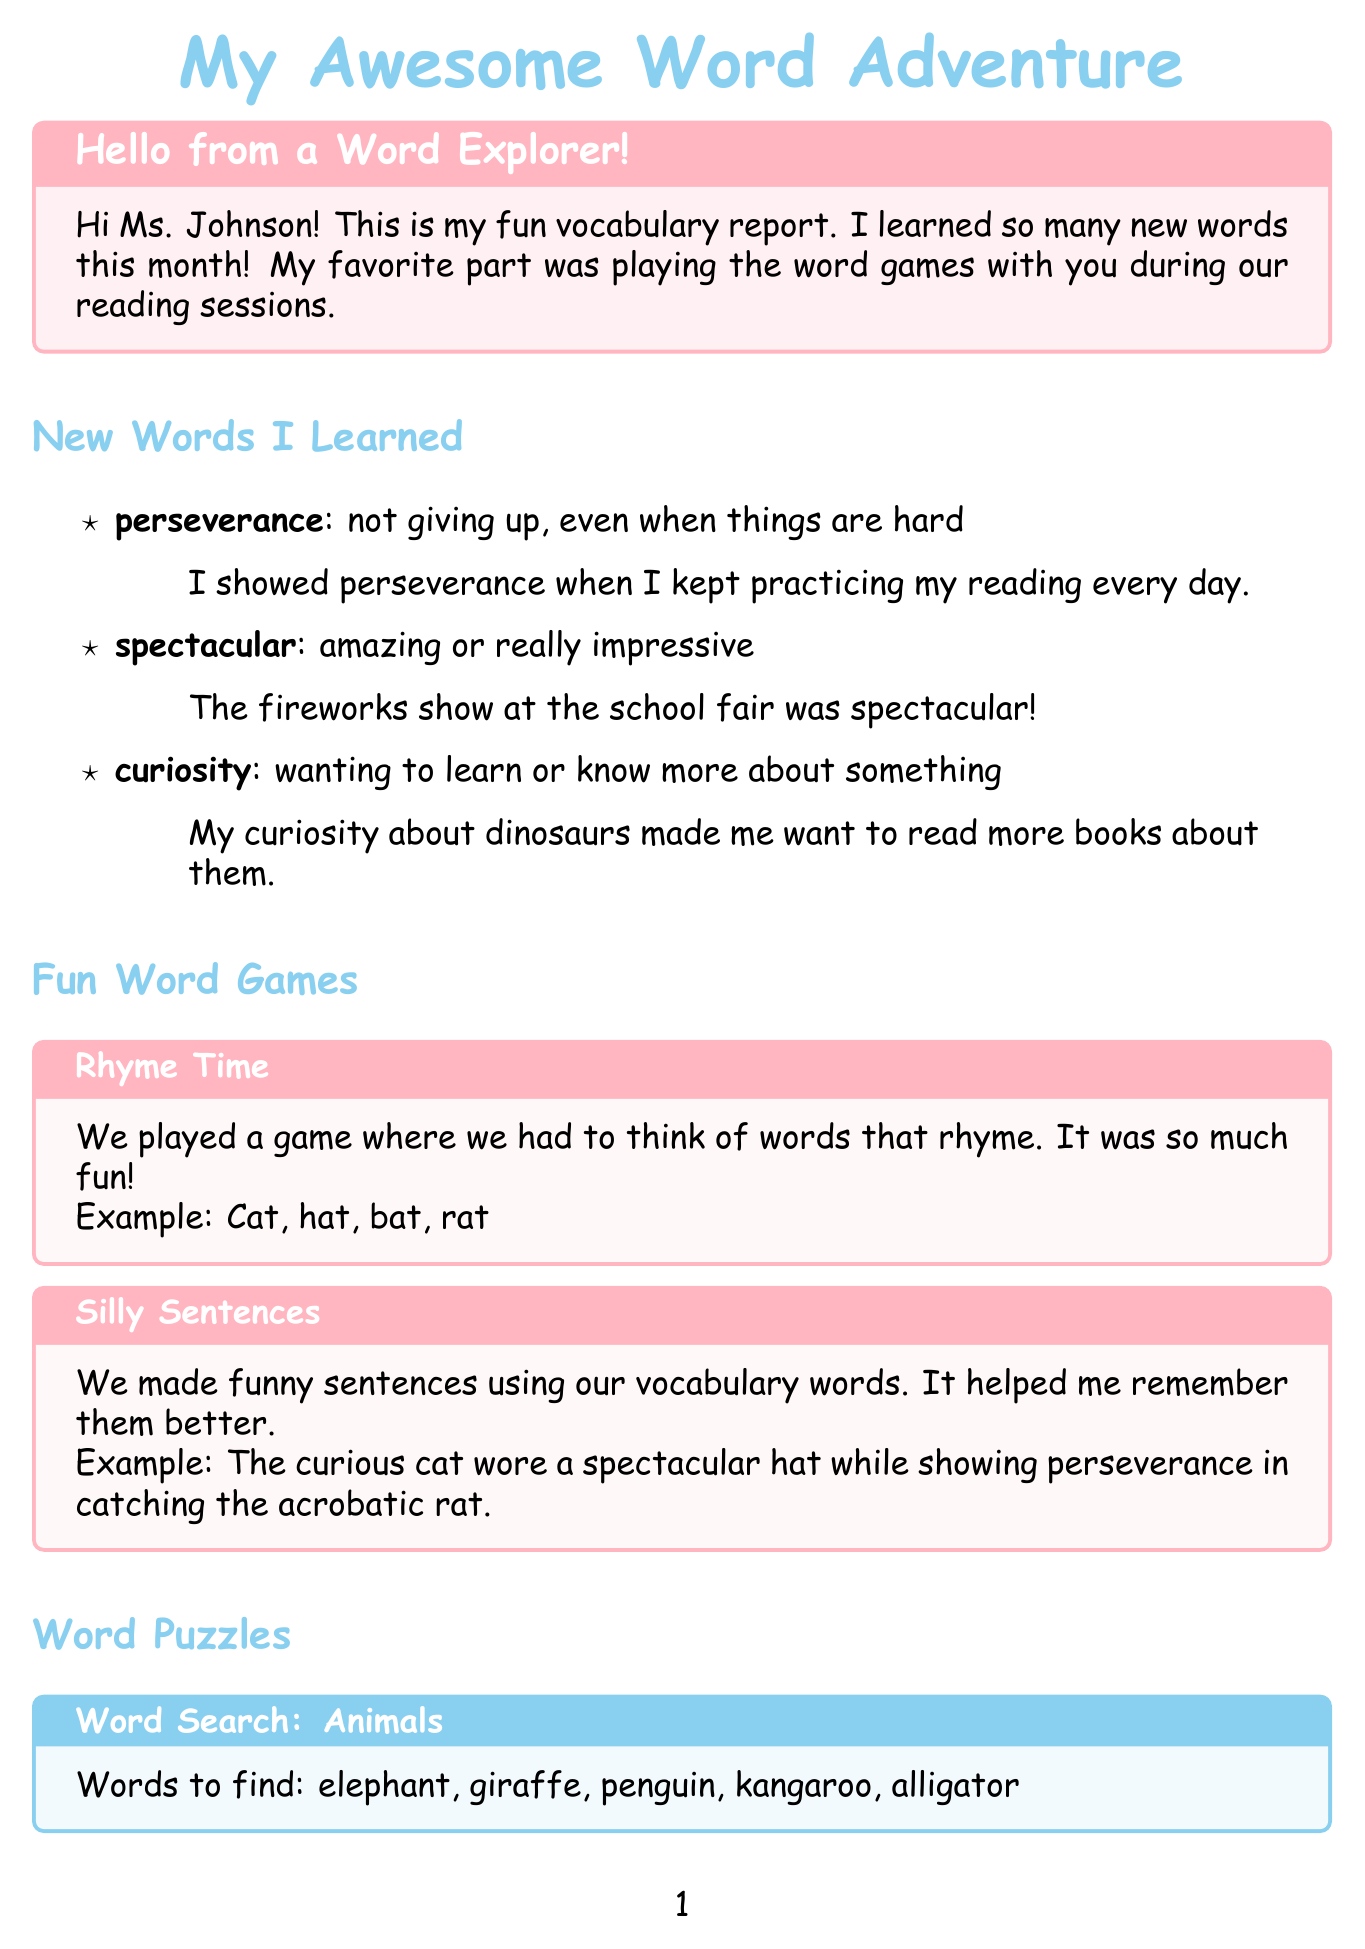What is the title of the report? The title of the report is presented at the beginning and indicates the subject of the document.
Answer: My Awesome Word Adventure Who is the report addressed to? The greeting in the introduction states who the report is directed at.
Answer: Ms. Johnson What is one new word learned? The section on new words lists specific words the reader learned, providing their meanings and usage.
Answer: perseverance What was the author's favorite activity? The introduction mentions a specific activity that the author enjoyed the most during the reading sessions.
Answer: playing the word games What type of game is "Rhyme Time"? The document describes the types of word games played, specifically naming one of them.
Answer: word game What is the goal mentioned in the personal progress section? The personal progress section states the author's goal they aim to achieve by the end of the school year.
Answer: Read a chapter book all by myself What was the theme of the Word Search puzzle? The type of word puzzles specifies the theme for one of the listed puzzles in the document.
Answer: Animals Why does the author like "Charlotte's Web"? The favorite book section explains the author's feelings towards the book, particularly on a specific aspect.
Answer: friendship between Wilbur and Charlotte How did the author express their gratitude? The conclusion of the report includes a statement reflecting the author's appreciation towards the teacher.
Answer: Thank you, Ms. Johnson, for helping me become a better reader! 